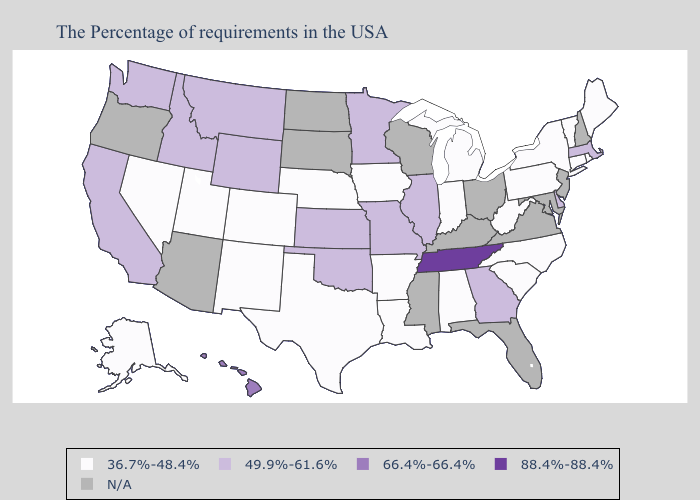What is the highest value in the USA?
Concise answer only. 88.4%-88.4%. Does Alabama have the highest value in the South?
Keep it brief. No. What is the lowest value in states that border Maryland?
Keep it brief. 36.7%-48.4%. Name the states that have a value in the range 49.9%-61.6%?
Give a very brief answer. Massachusetts, Delaware, Georgia, Illinois, Missouri, Minnesota, Kansas, Oklahoma, Wyoming, Montana, Idaho, California, Washington. Name the states that have a value in the range 88.4%-88.4%?
Quick response, please. Tennessee. What is the value of Alabama?
Keep it brief. 36.7%-48.4%. What is the value of Oklahoma?
Write a very short answer. 49.9%-61.6%. Does Arkansas have the lowest value in the USA?
Concise answer only. Yes. Name the states that have a value in the range 66.4%-66.4%?
Write a very short answer. Hawaii. Name the states that have a value in the range 36.7%-48.4%?
Keep it brief. Maine, Rhode Island, Vermont, Connecticut, New York, Pennsylvania, North Carolina, South Carolina, West Virginia, Michigan, Indiana, Alabama, Louisiana, Arkansas, Iowa, Nebraska, Texas, Colorado, New Mexico, Utah, Nevada, Alaska. Does Tennessee have the highest value in the USA?
Answer briefly. Yes. What is the value of Missouri?
Keep it brief. 49.9%-61.6%. Among the states that border Nebraska , does Missouri have the lowest value?
Write a very short answer. No. 